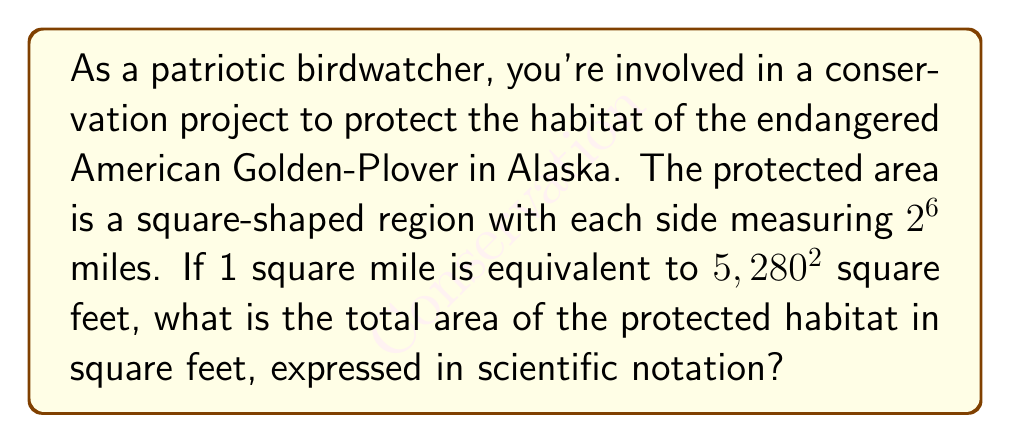Can you solve this math problem? Let's approach this step-by-step:

1) First, we need to calculate the area of the square-shaped protected region in square miles:
   - Side length = $2^6$ miles = 64 miles
   - Area = side length squared = $(2^6)^2 = 2^{12}$ square miles

2) Now, we need to convert square miles to square feet:
   - 1 square mile = $5,280^2$ square feet
   - So, we multiply our area by $5,280^2$

3) The calculation:
   $$(2^{12}) \cdot (5,280^2) = 2^{12} \cdot 5,280^2$$

4) Let's simplify $5,280^2$:
   $$5,280^2 = 27,878,400 = 2.78784 \times 10^7$$

5) Now our calculation looks like:
   $$2^{12} \cdot (2.78784 \times 10^7)$$

6) $2^{12} = 4,096 = 4.096 \times 10^3$

7) So we have:
   $$(4.096 \times 10^3) \cdot (2.78784 \times 10^7) = 11.429 \times 10^{10}$$

8) Rounding to 3 significant figures and expressing in scientific notation:
   $$1.14 \times 10^{11} \text{ square feet}$$
Answer: $1.14 \times 10^{11}$ square feet 